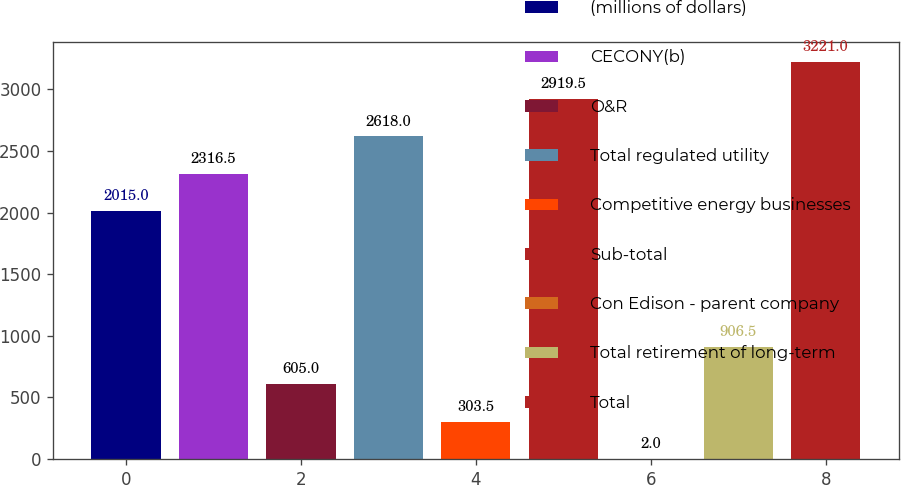Convert chart. <chart><loc_0><loc_0><loc_500><loc_500><bar_chart><fcel>(millions of dollars)<fcel>CECONY(b)<fcel>O&R<fcel>Total regulated utility<fcel>Competitive energy businesses<fcel>Sub-total<fcel>Con Edison - parent company<fcel>Total retirement of long-term<fcel>Total<nl><fcel>2015<fcel>2316.5<fcel>605<fcel>2618<fcel>303.5<fcel>2919.5<fcel>2<fcel>906.5<fcel>3221<nl></chart> 